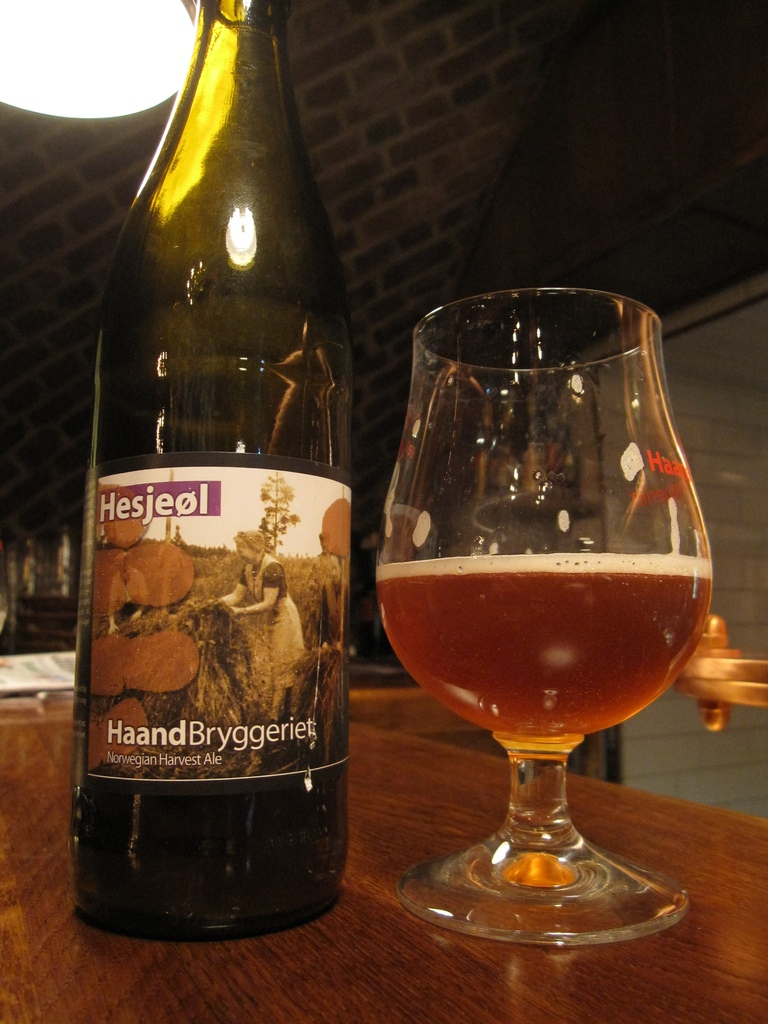What can you tell about the type of beer shown in the image? The image features a Norwegian Harvest Ale, known as 'Hesjeol', characterized by its amber color and potentially rich, malty flavor profile, suitable for seasonal harvesting times. 